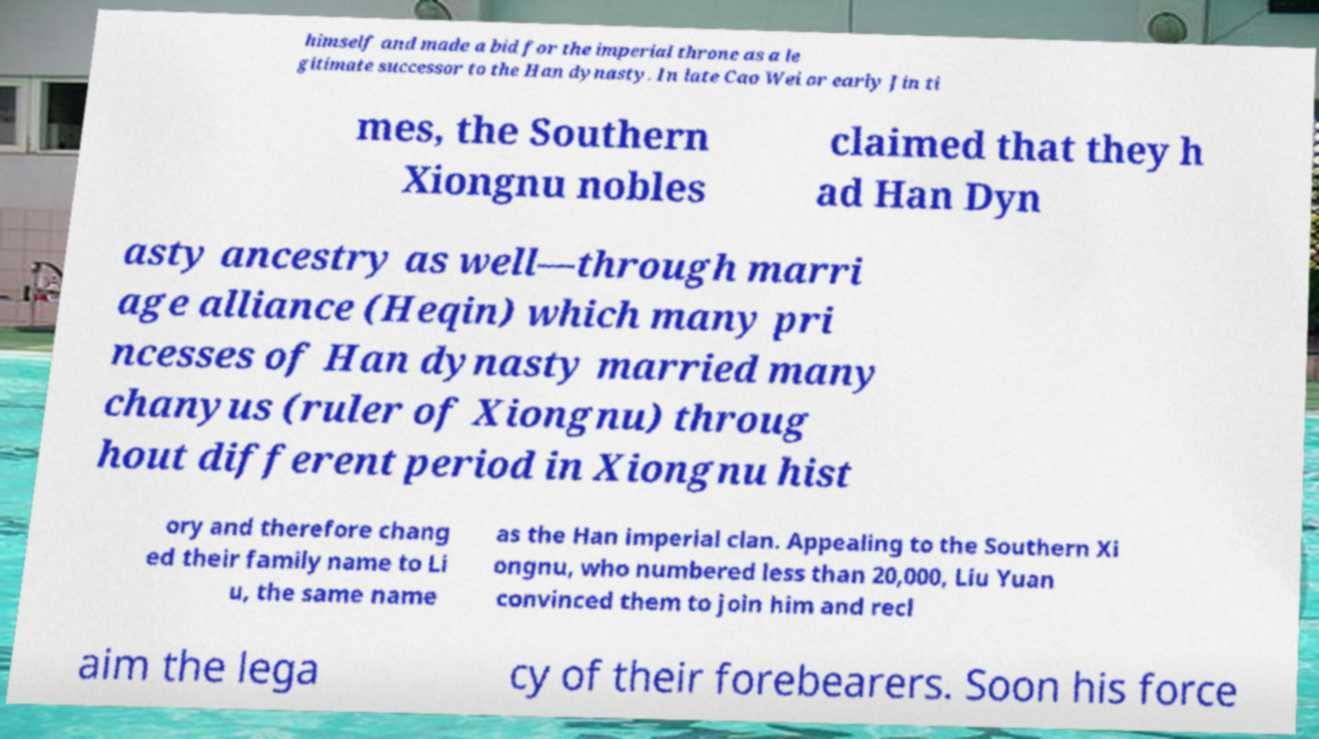I need the written content from this picture converted into text. Can you do that? himself and made a bid for the imperial throne as a le gitimate successor to the Han dynasty. In late Cao Wei or early Jin ti mes, the Southern Xiongnu nobles claimed that they h ad Han Dyn asty ancestry as well—through marri age alliance (Heqin) which many pri ncesses of Han dynasty married many chanyus (ruler of Xiongnu) throug hout different period in Xiongnu hist ory and therefore chang ed their family name to Li u, the same name as the Han imperial clan. Appealing to the Southern Xi ongnu, who numbered less than 20,000, Liu Yuan convinced them to join him and recl aim the lega cy of their forebearers. Soon his force 